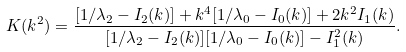Convert formula to latex. <formula><loc_0><loc_0><loc_500><loc_500>K ( k ^ { 2 } ) = \frac { [ 1 / \lambda _ { 2 } - I _ { 2 } ( k ) ] + k ^ { 4 } [ 1 / \lambda _ { 0 } - I _ { 0 } ( k ) ] + 2 k ^ { 2 } I _ { 1 } ( k ) } { [ 1 / \lambda _ { 2 } - I _ { 2 } ( k ) ] [ 1 / \lambda _ { 0 } - I _ { 0 } ( k ) ] - I _ { 1 } ^ { 2 } ( k ) } .</formula> 